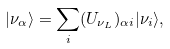<formula> <loc_0><loc_0><loc_500><loc_500>| \nu _ { \alpha } \rangle = \sum _ { i } ( U _ { \nu _ { L } } ) _ { \alpha i } | \nu _ { i } \rangle ,</formula> 